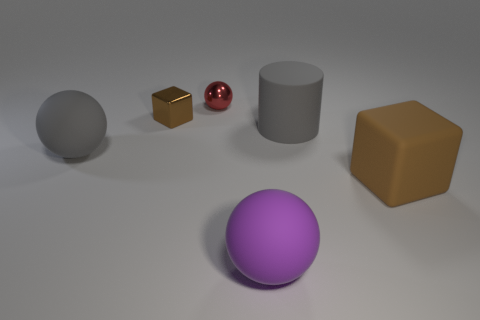Subtract all big gray rubber balls. How many balls are left? 2 Add 2 red metal balls. How many objects exist? 8 Subtract all cylinders. How many objects are left? 5 Subtract 1 spheres. How many spheres are left? 2 Subtract all large purple objects. Subtract all gray matte objects. How many objects are left? 3 Add 1 large matte blocks. How many large matte blocks are left? 2 Add 3 small cyan matte spheres. How many small cyan matte spheres exist? 3 Subtract 1 brown blocks. How many objects are left? 5 Subtract all gray blocks. Subtract all yellow cylinders. How many blocks are left? 2 